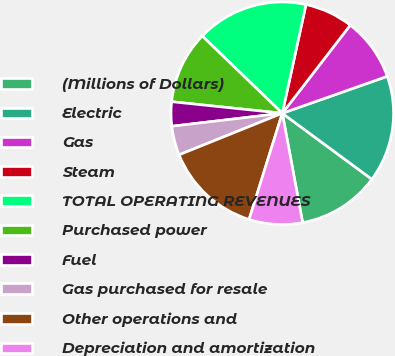<chart> <loc_0><loc_0><loc_500><loc_500><pie_chart><fcel>(Millions of Dollars)<fcel>Electric<fcel>Gas<fcel>Steam<fcel>TOTAL OPERATING REVENUES<fcel>Purchased power<fcel>Fuel<fcel>Gas purchased for resale<fcel>Other operations and<fcel>Depreciation and amortization<nl><fcel>11.97%<fcel>15.49%<fcel>9.16%<fcel>7.04%<fcel>16.2%<fcel>10.56%<fcel>3.52%<fcel>4.23%<fcel>14.08%<fcel>7.75%<nl></chart> 